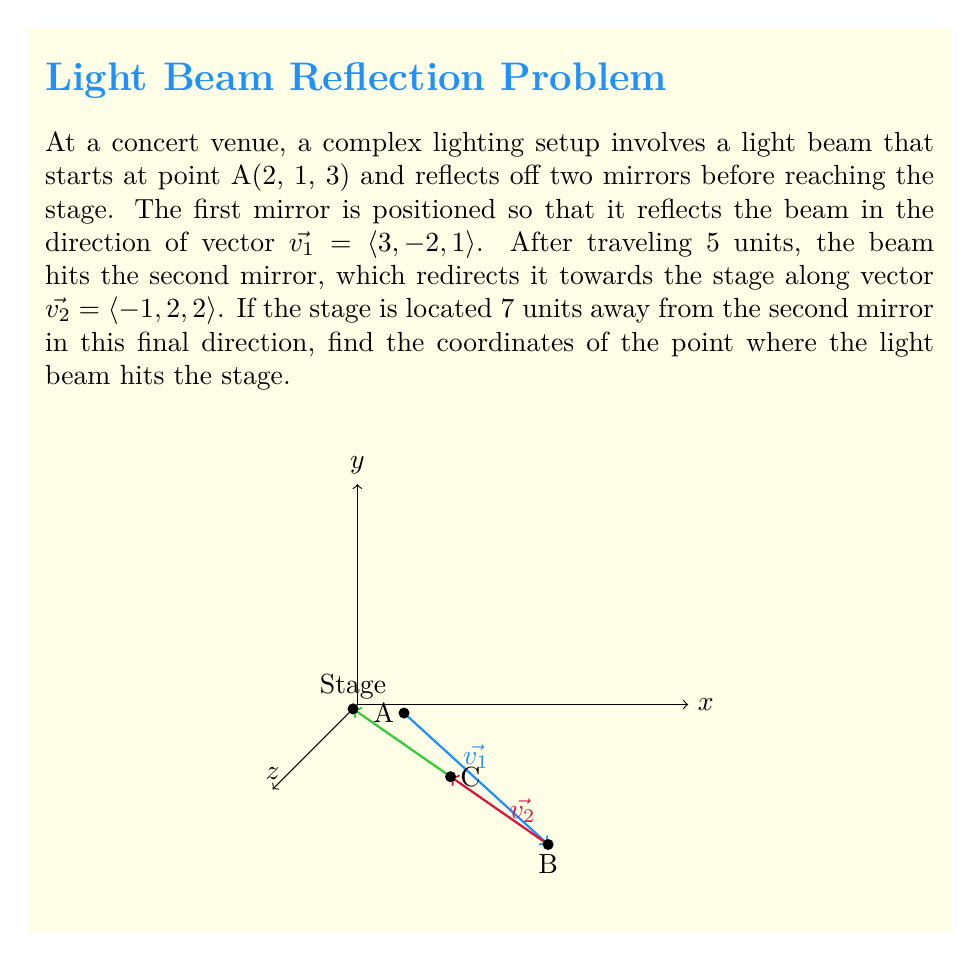Provide a solution to this math problem. Let's approach this step-by-step:

1) First, we need to find the point B where the beam hits the first mirror. We can do this using the vector equation of a line:
   $$B = A + t\vec{v_1}$$
   where t = 5 (the distance traveled)
   
   $$B = (2, 1, 3) + 5\langle 3, -2, 1 \rangle = (2, 1, 3) + (15, -10, 5) = (17, -9, 8)$$

2) Now, we need to find point C where the beam hits the second mirror. We can use the same method:
   $$C = B + 5\vec{v_1}$$
   $$C = (17, -9, 8) + 5\langle 3, -2, 1 \rangle = (17, -9, 8) + (15, -10, 5) = (32, -19, 13)$$

3) Finally, we can find the point where the beam hits the stage. Let's call this point S:
   $$S = C + 7\vec{v_2}$$
   $$S = (32, -19, 13) + 7\langle -1, 2, 2 \rangle = (32, -19, 13) + (-7, 14, 14) = (25, -5, 27)$$

Therefore, the light beam hits the stage at the point (25, -5, 27).
Answer: (25, -5, 27) 